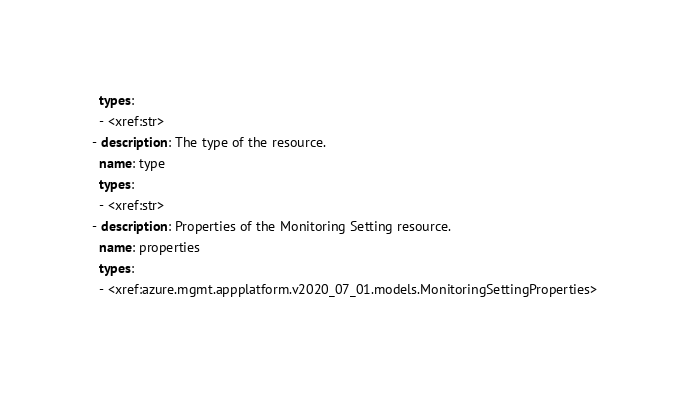Convert code to text. <code><loc_0><loc_0><loc_500><loc_500><_YAML_>  types:
  - <xref:str>
- description: The type of the resource.
  name: type
  types:
  - <xref:str>
- description: Properties of the Monitoring Setting resource.
  name: properties
  types:
  - <xref:azure.mgmt.appplatform.v2020_07_01.models.MonitoringSettingProperties>
</code> 